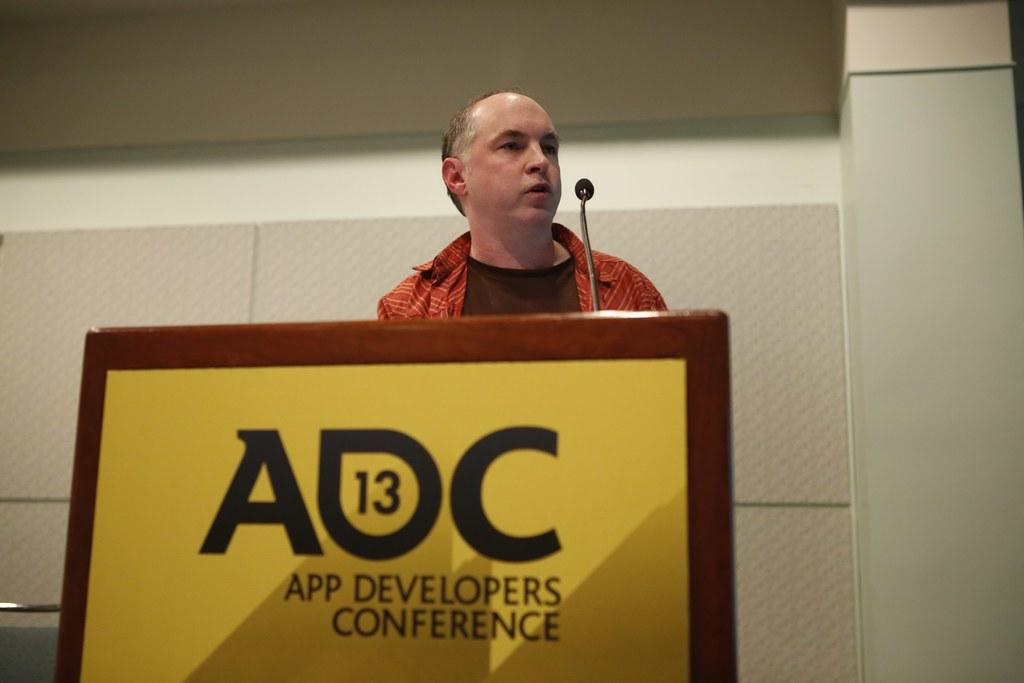Who is the main subject in the image? There is a man in the image. What is the man doing in the image? The man is standing behind a podium. What object is the man holding in the image? The man is holding a microphone. What can be seen in the background of the image? There is a wall in the background of the image. What type of scale is visible on the dock in the image? There is no scale or dock present in the image. How many quarters can be seen on the man's hand in the image? There are no quarters visible on the man's hand in the image. 